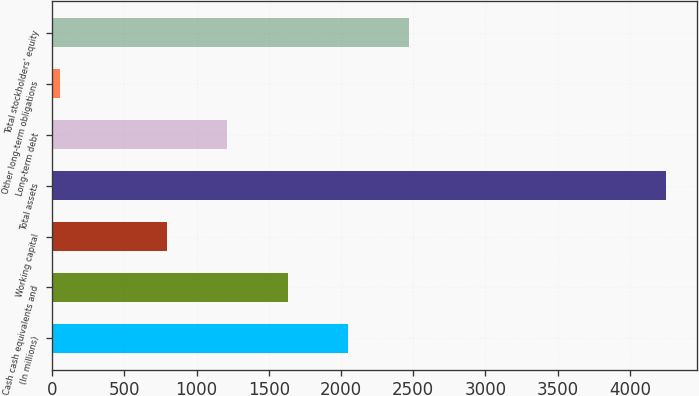Convert chart to OTSL. <chart><loc_0><loc_0><loc_500><loc_500><bar_chart><fcel>(In millions)<fcel>Cash cash equivalents and<fcel>Working capital<fcel>Total assets<fcel>Long-term debt<fcel>Other long-term obligations<fcel>Total stockholders' equity<nl><fcel>2050.5<fcel>1631<fcel>792<fcel>4252<fcel>1211.5<fcel>57<fcel>2470<nl></chart> 